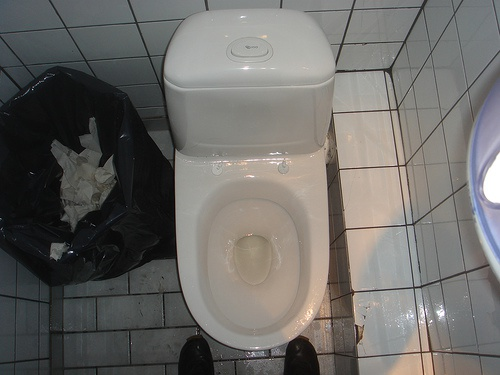Describe the objects in this image and their specific colors. I can see a toilet in purple, darkgray, gray, and tan tones in this image. 